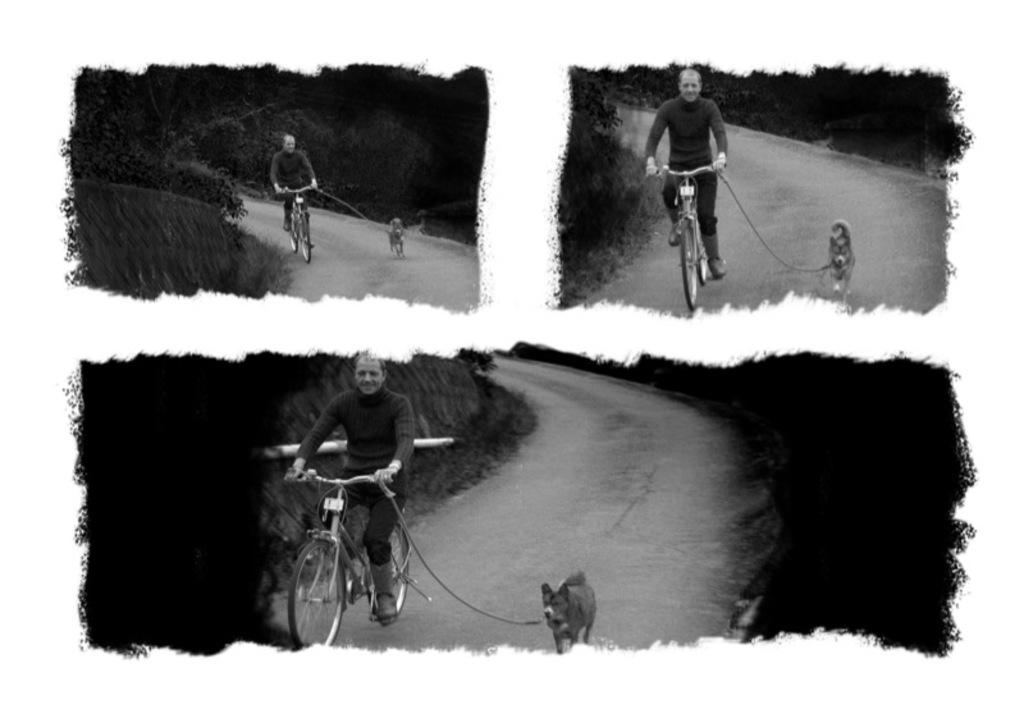What type of artwork is the image? The image is a collage. What activity is being depicted in the image? There is a person riding a cycle on the road. Is there any animal present in the image? Yes, there is a dog beside the cycle. What can be seen in the background of the image? There are trees in the background of the image. What type of bone can be seen in the image? There is no bone present in the image. Is the person riding the cycle missing an arm in the image? No, the person riding the cycle has both arms in the image. 